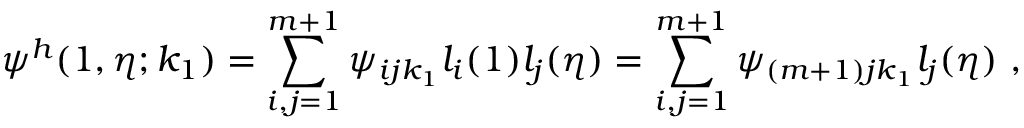Convert formula to latex. <formula><loc_0><loc_0><loc_500><loc_500>\psi ^ { h } ( 1 , \eta ; k _ { 1 } ) = \sum _ { i , j = 1 } ^ { m + 1 } { \psi _ { i j k _ { 1 } } l _ { i } ( 1 ) l _ { j } ( \eta ) } = \sum _ { i , j = 1 } ^ { m + 1 } { \psi _ { ( m + 1 ) j k _ { 1 } } l _ { j } ( \eta ) } ,</formula> 